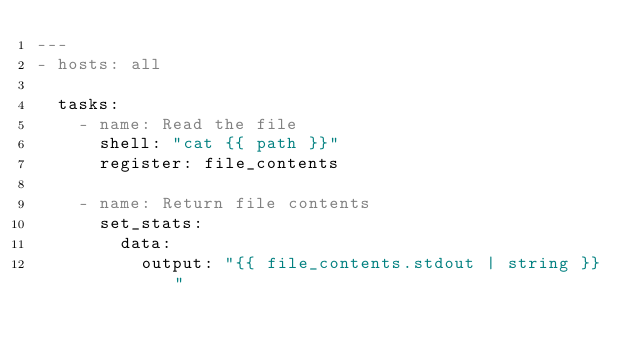<code> <loc_0><loc_0><loc_500><loc_500><_YAML_>---
- hosts: all

  tasks:
    - name: Read the file
      shell: "cat {{ path }}"
      register: file_contents

    - name: Return file contents
      set_stats:
        data:
          output: "{{ file_contents.stdout | string }}"</code> 